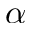<formula> <loc_0><loc_0><loc_500><loc_500>\alpha</formula> 